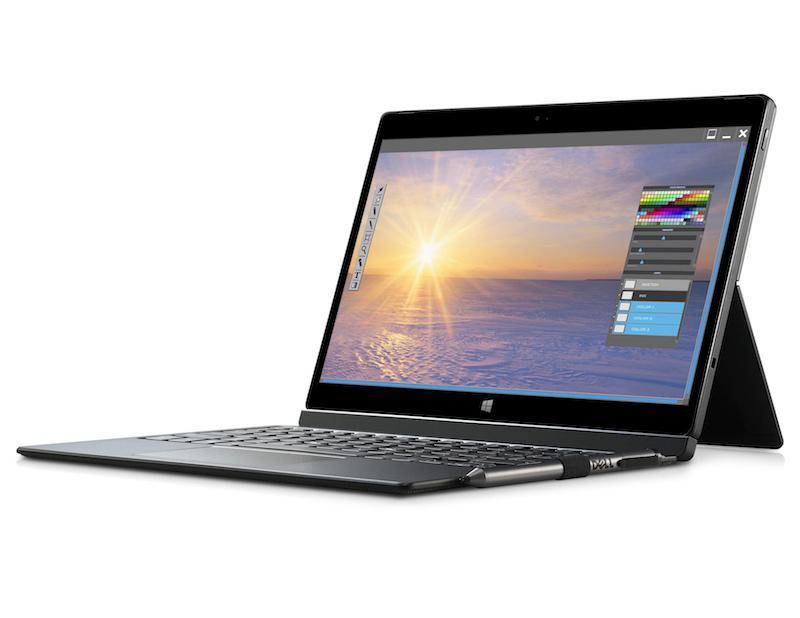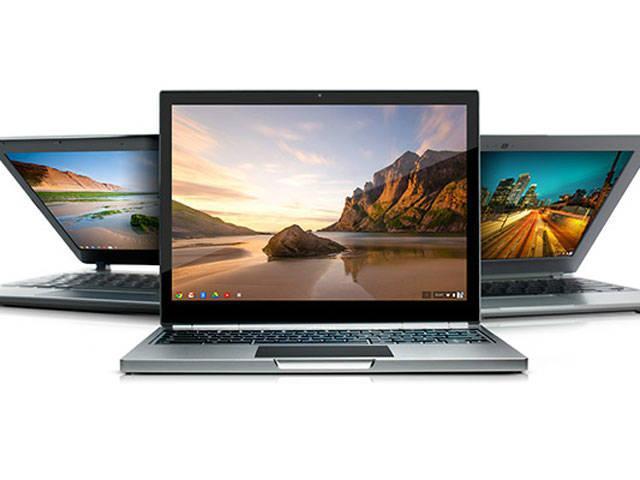The first image is the image on the left, the second image is the image on the right. Analyze the images presented: Is the assertion "there are two laptops fully open in the image pair" valid? Answer yes or no. No. 